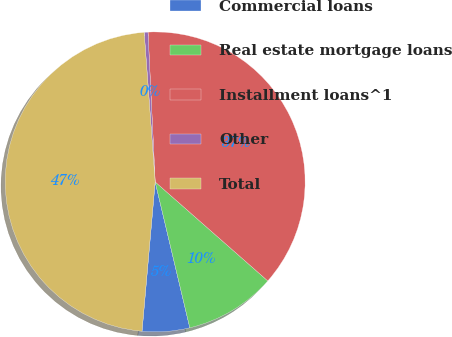Convert chart to OTSL. <chart><loc_0><loc_0><loc_500><loc_500><pie_chart><fcel>Commercial loans<fcel>Real estate mortgage loans<fcel>Installment loans^1<fcel>Other<fcel>Total<nl><fcel>5.11%<fcel>9.81%<fcel>37.24%<fcel>0.41%<fcel>47.43%<nl></chart> 